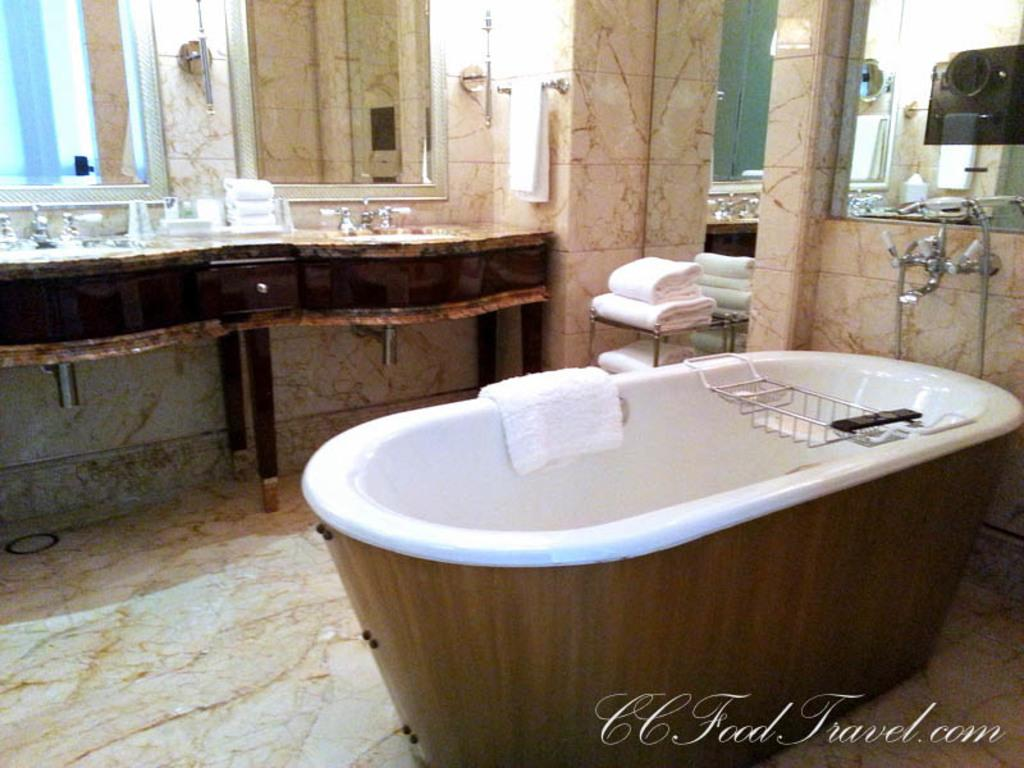What is the main object in the foreground of the image? There is a bathtub in the foreground of the image. What items might be used for drying or cleaning in the image? Towels are present in the image for drying or cleaning. What feature is used for controlling the flow of water in the image? A tap is visible in the image for controlling the flow of water. What piece of furniture can be seen in the image? There is a table in the image. What objects might be used for personal grooming or reflection in the image? Mirrors are present in the image for personal grooming or reflection. What type of space is depicted in the image? The image is taken in a room. What type of ghost can be seen in the image? There is no ghost present in the image; it is a room with a bathtub, towels, a tap, a table, mirrors, and a wall. What kind of needle is being used to sew the wren in the image? There is no needle or wren present in the image. 